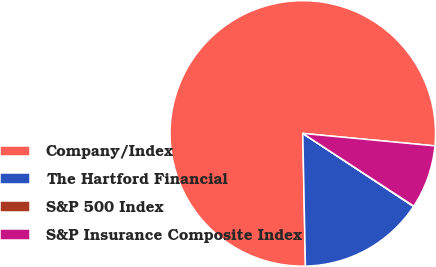Convert chart. <chart><loc_0><loc_0><loc_500><loc_500><pie_chart><fcel>Company/Index<fcel>The Hartford Financial<fcel>S&P 500 Index<fcel>S&P Insurance Composite Index<nl><fcel>76.81%<fcel>15.4%<fcel>0.05%<fcel>7.73%<nl></chart> 